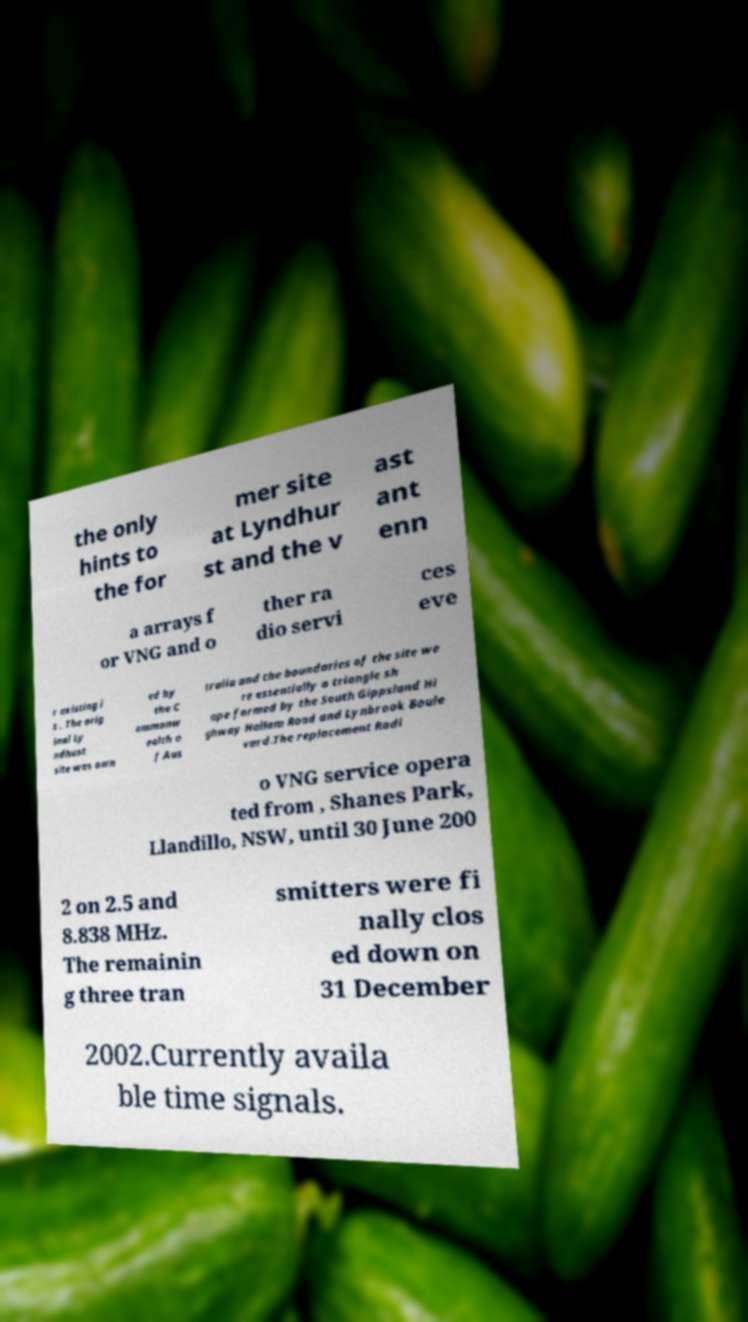I need the written content from this picture converted into text. Can you do that? the only hints to the for mer site at Lyndhur st and the v ast ant enn a arrays f or VNG and o ther ra dio servi ces eve r existing i s . The orig inal Ly ndhust site was own ed by the C ommonw ealth o f Aus tralia and the boundaries of the site we re essentially a triangle sh ape formed by the South Gippsland Hi ghway Hallam Road and Lynbrook Boule vard.The replacement Radi o VNG service opera ted from , Shanes Park, Llandillo, NSW, until 30 June 200 2 on 2.5 and 8.838 MHz. The remainin g three tran smitters were fi nally clos ed down on 31 December 2002.Currently availa ble time signals. 